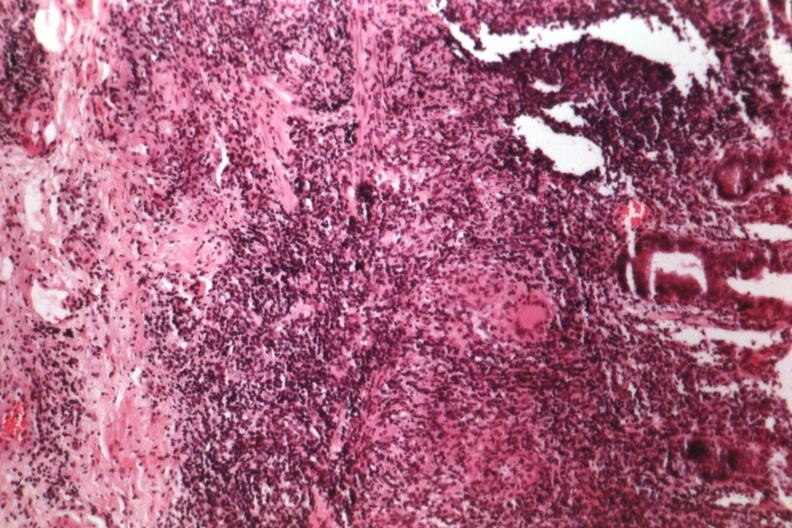does this image show source of granulomatous colitis?
Answer the question using a single word or phrase. Yes 